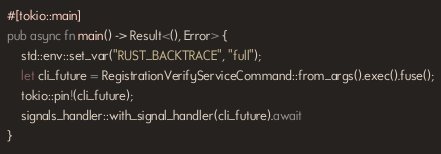Convert code to text. <code><loc_0><loc_0><loc_500><loc_500><_Rust_>#[tokio::main]
pub async fn main() -> Result<(), Error> {
    std::env::set_var("RUST_BACKTRACE", "full");
    let cli_future = RegistrationVerifyServiceCommand::from_args().exec().fuse();
    tokio::pin!(cli_future);
    signals_handler::with_signal_handler(cli_future).await
}
</code> 